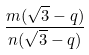<formula> <loc_0><loc_0><loc_500><loc_500>\frac { m ( \sqrt { 3 } - q ) } { n ( \sqrt { 3 } - q ) }</formula> 